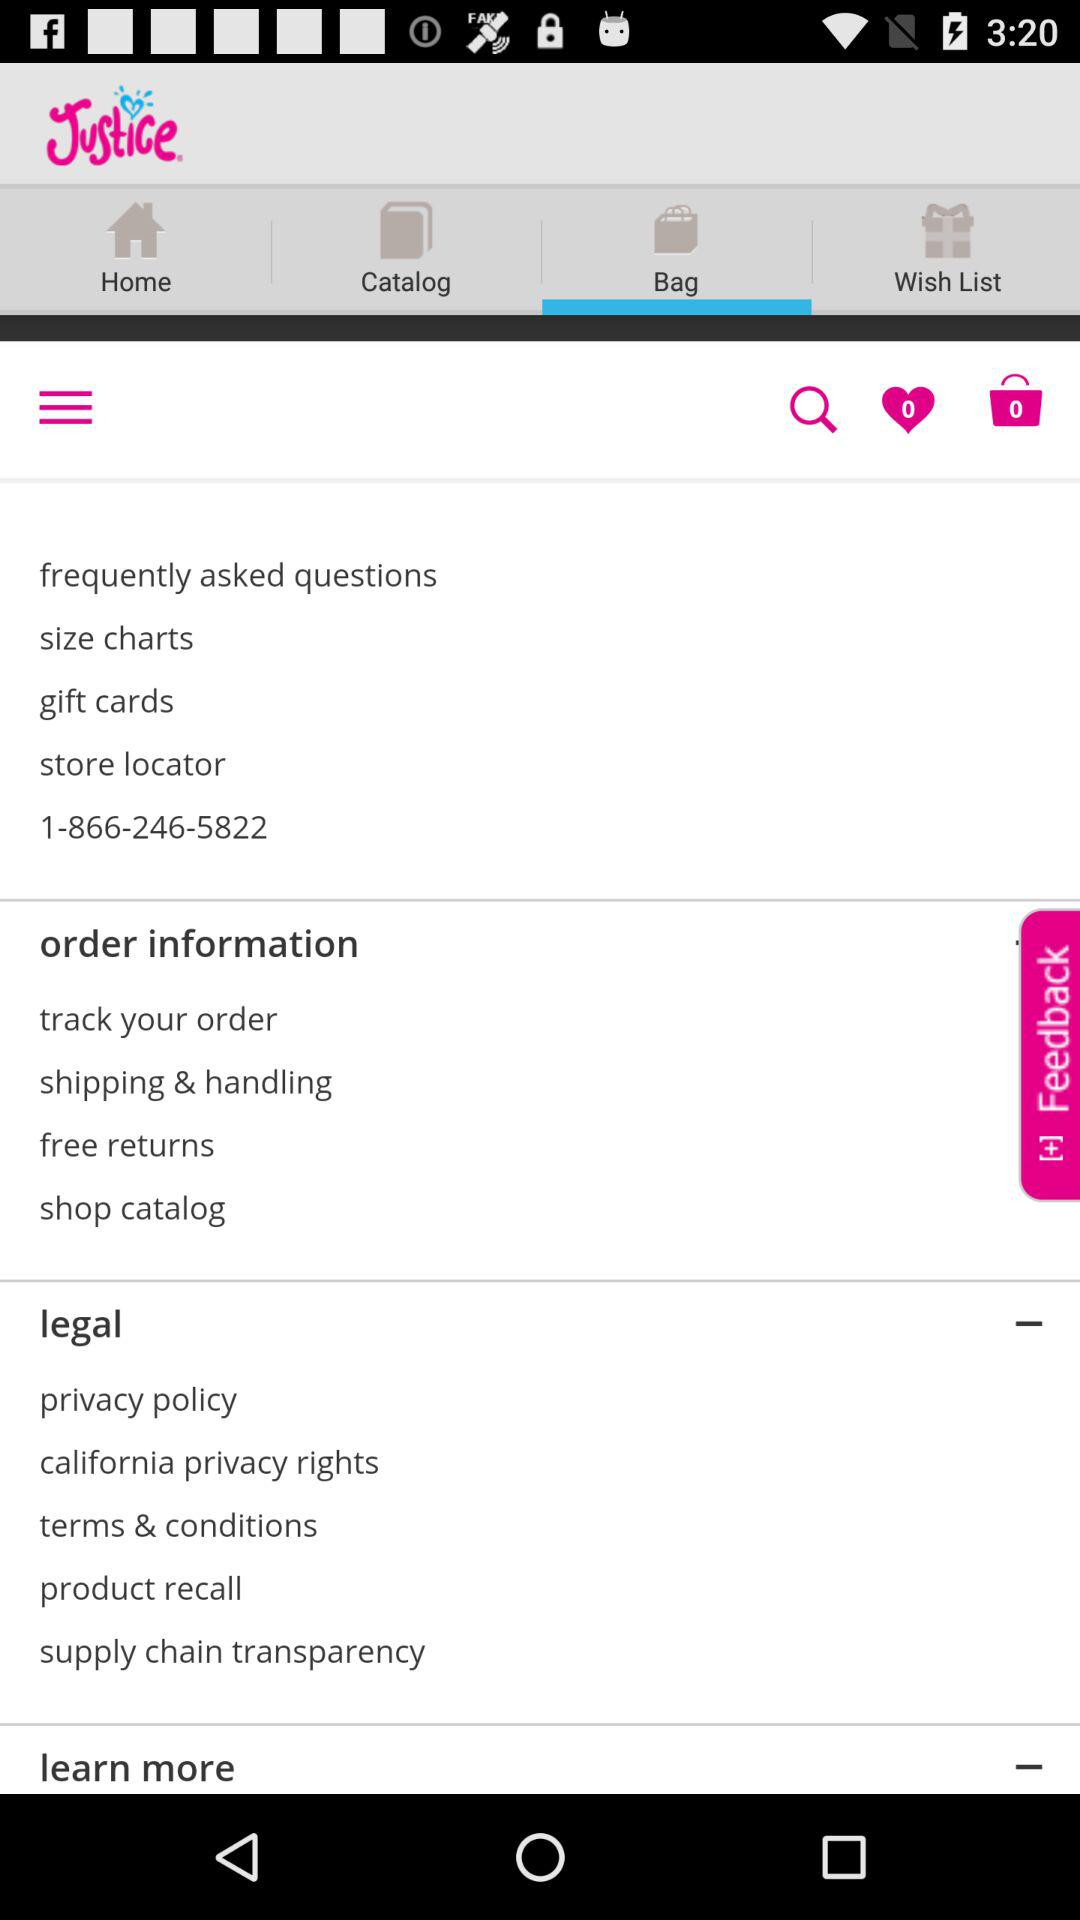Which tab is open? The opened tab is "Bag". 